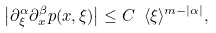<formula> <loc_0><loc_0><loc_500><loc_500>\left | \partial _ { \xi } ^ { \alpha } \partial _ { x } ^ { \beta } p ( x , \xi ) \right | \leq C \ \langle \xi \rangle ^ { m - | \alpha | } ,</formula> 